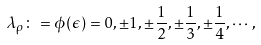Convert formula to latex. <formula><loc_0><loc_0><loc_500><loc_500>\lambda _ { \rho } \colon = \phi ( \epsilon ) = 0 , \pm 1 , \pm \frac { 1 } { 2 } , \pm \frac { 1 } { 3 } , \pm \frac { 1 } { 4 } , \cdots ,</formula> 